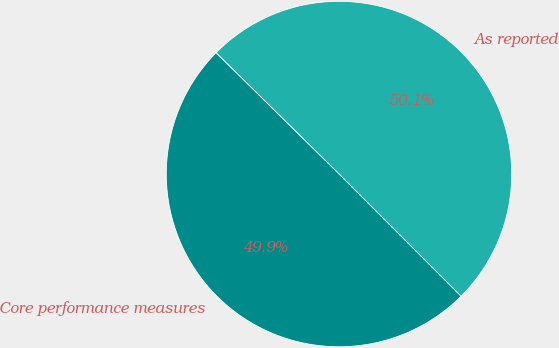<chart> <loc_0><loc_0><loc_500><loc_500><pie_chart><fcel>As reported<fcel>Core performance measures<nl><fcel>50.13%<fcel>49.87%<nl></chart> 